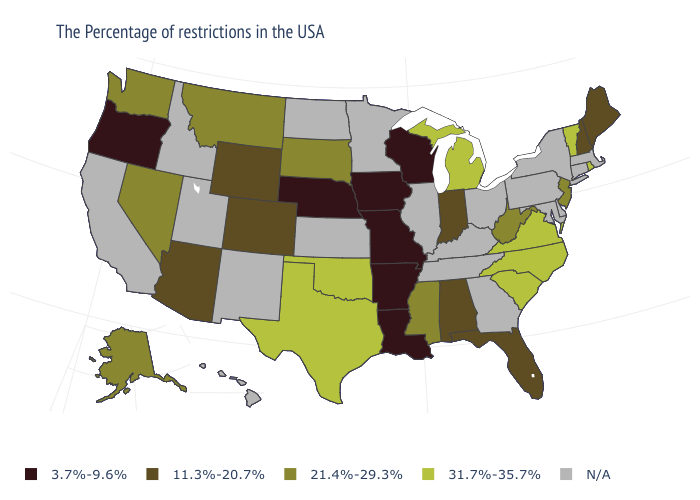Name the states that have a value in the range 11.3%-20.7%?
Keep it brief. Maine, New Hampshire, Florida, Indiana, Alabama, Wyoming, Colorado, Arizona. Name the states that have a value in the range N/A?
Write a very short answer. Massachusetts, Connecticut, New York, Delaware, Maryland, Pennsylvania, Ohio, Georgia, Kentucky, Tennessee, Illinois, Minnesota, Kansas, North Dakota, New Mexico, Utah, Idaho, California, Hawaii. What is the value of Connecticut?
Be succinct. N/A. What is the lowest value in the USA?
Answer briefly. 3.7%-9.6%. Does Arkansas have the lowest value in the USA?
Give a very brief answer. Yes. What is the value of Tennessee?
Concise answer only. N/A. What is the value of Minnesota?
Be succinct. N/A. What is the value of Vermont?
Be succinct. 31.7%-35.7%. Name the states that have a value in the range 3.7%-9.6%?
Give a very brief answer. Wisconsin, Louisiana, Missouri, Arkansas, Iowa, Nebraska, Oregon. What is the lowest value in states that border Washington?
Keep it brief. 3.7%-9.6%. What is the highest value in the USA?
Short answer required. 31.7%-35.7%. Does South Dakota have the lowest value in the USA?
Concise answer only. No. What is the value of Oregon?
Quick response, please. 3.7%-9.6%. Name the states that have a value in the range 3.7%-9.6%?
Short answer required. Wisconsin, Louisiana, Missouri, Arkansas, Iowa, Nebraska, Oregon. 